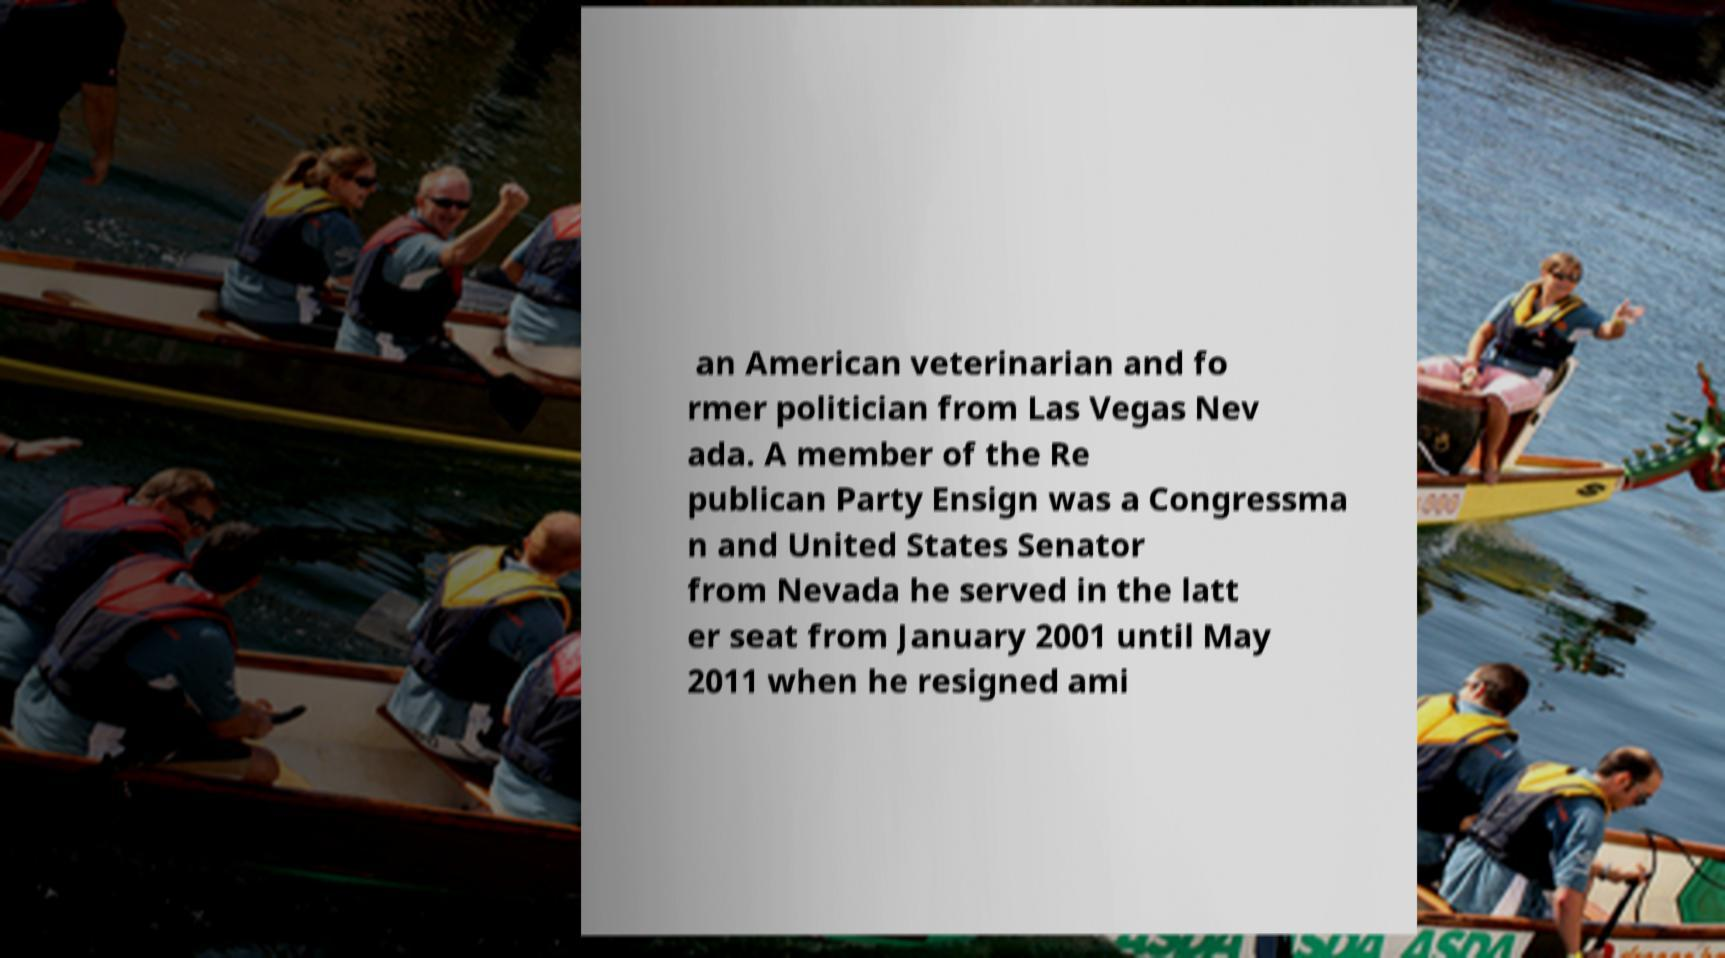There's text embedded in this image that I need extracted. Can you transcribe it verbatim? an American veterinarian and fo rmer politician from Las Vegas Nev ada. A member of the Re publican Party Ensign was a Congressma n and United States Senator from Nevada he served in the latt er seat from January 2001 until May 2011 when he resigned ami 